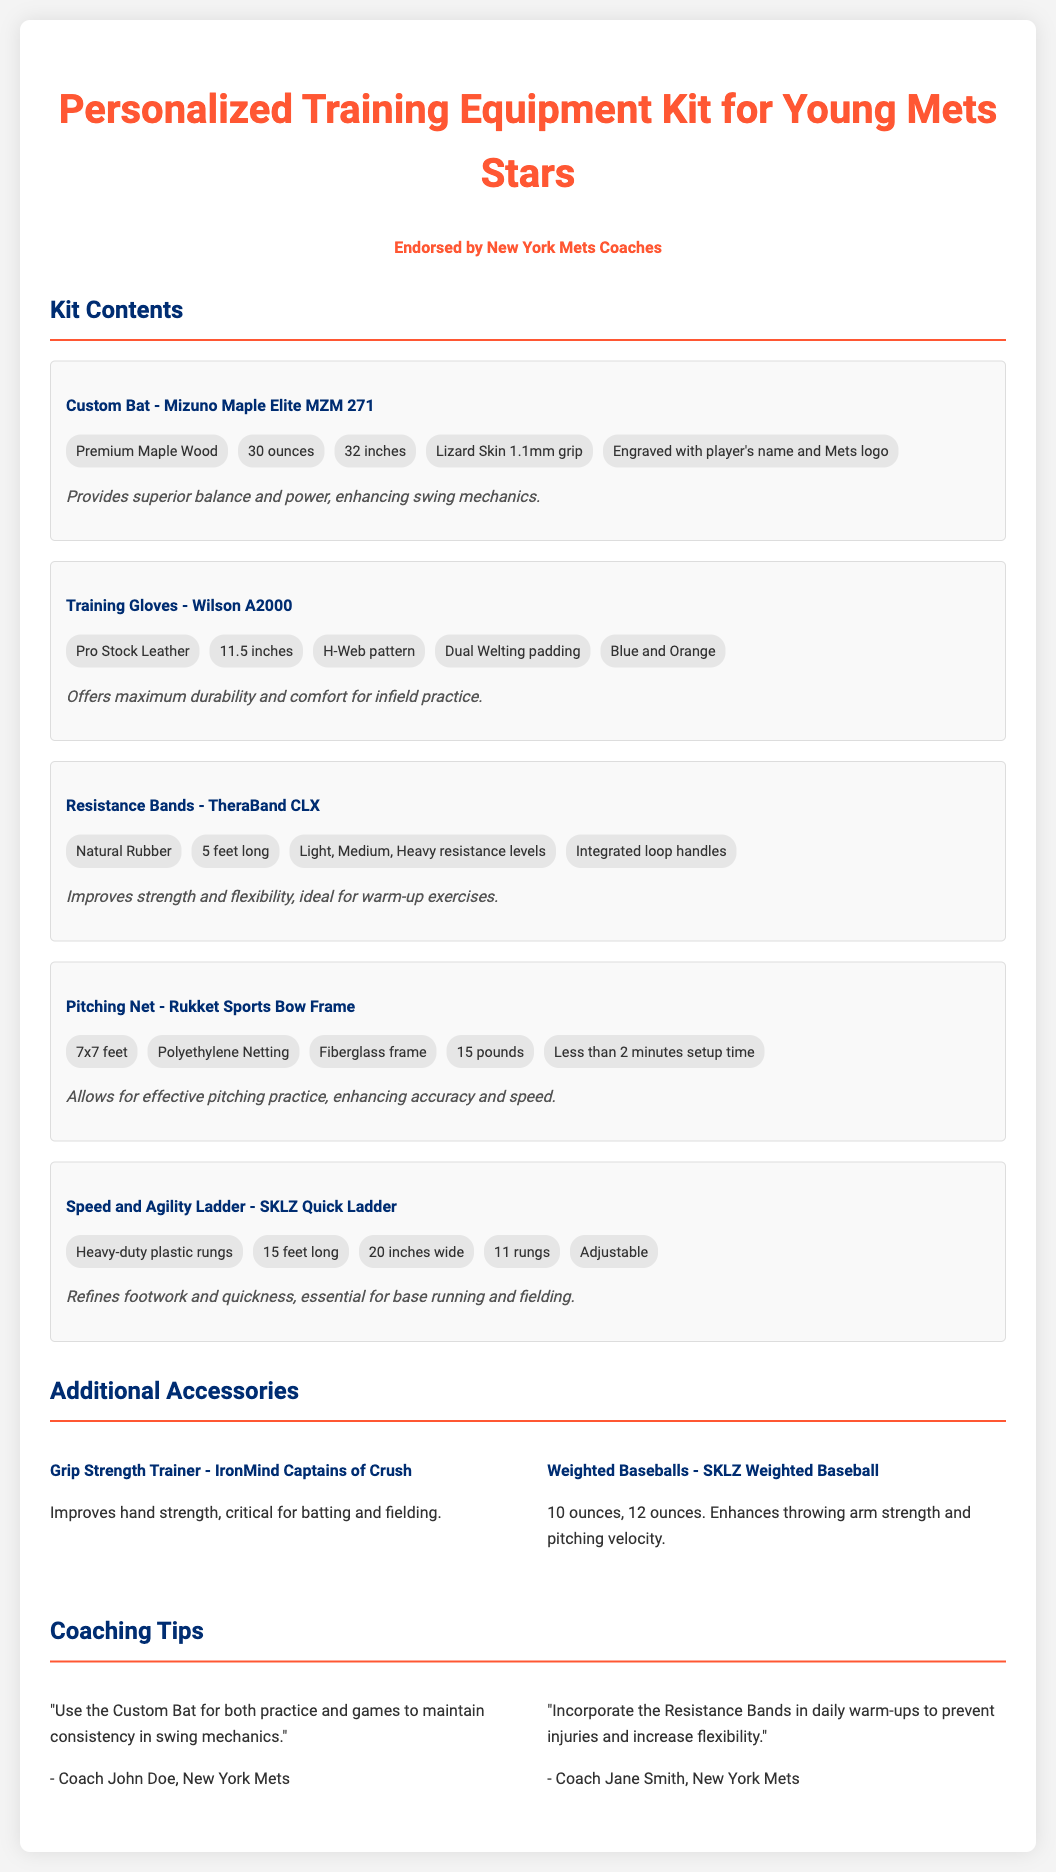What is the name of the custom bat? The custom bat is referred to as the Mizuno Maple Elite MZM 271.
Answer: Mizuno Maple Elite MZM 271 How much does the pitching net weigh? The pitching net weighs 15 pounds, as indicated in the specifications.
Answer: 15 pounds What material is used for the training gloves? The training gloves are made of Pro Stock Leather.
Answer: Pro Stock Leather What is the length of the resistance bands? The resistance bands are 5 feet long.
Answer: 5 feet Who endorsed the training equipment kit? The training equipment kit is endorsed by New York Mets Coaches.
Answer: New York Mets Coaches What type of grip does the custom bat have? The custom bat features a Lizard Skin 1.1mm grip.
Answer: Lizard Skin 1.1mm grip What is the width of the speed and agility ladder? The speed and agility ladder is 20 inches wide.
Answer: 20 inches What benefits does the pitching net provide? The pitching net allows for effective pitching practice, enhancing accuracy and speed.
Answer: Enhancing accuracy and speed What is the purpose of the grip strength trainer? The grip strength trainer improves hand strength, which is critical for batting and fielding.
Answer: Improves hand strength 